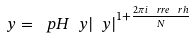<formula> <loc_0><loc_0><loc_500><loc_500>\ y = \ p H { \ y } | \ y | ^ { 1 + \frac { 2 \pi i \ r r e { \ r h } } { N } }</formula> 